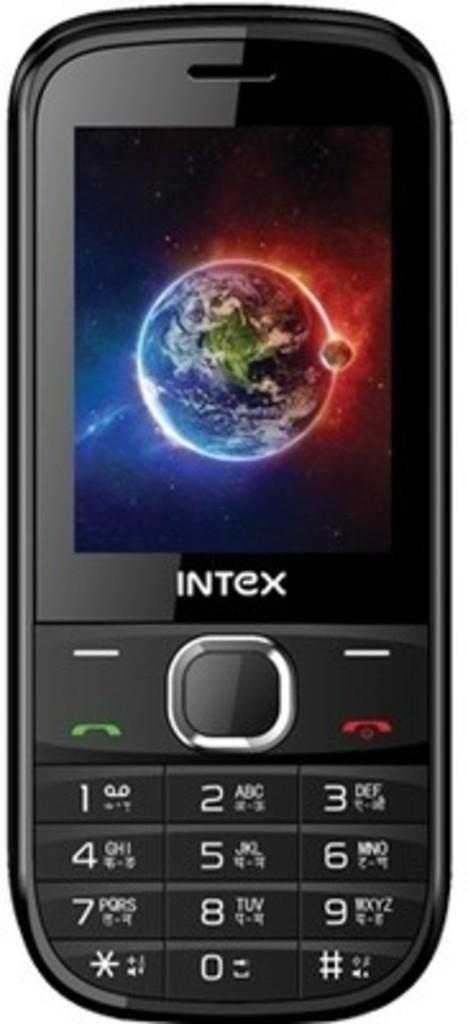<image>
Offer a succinct explanation of the picture presented. An Intex cell phone has a picture of the earth as its background. 